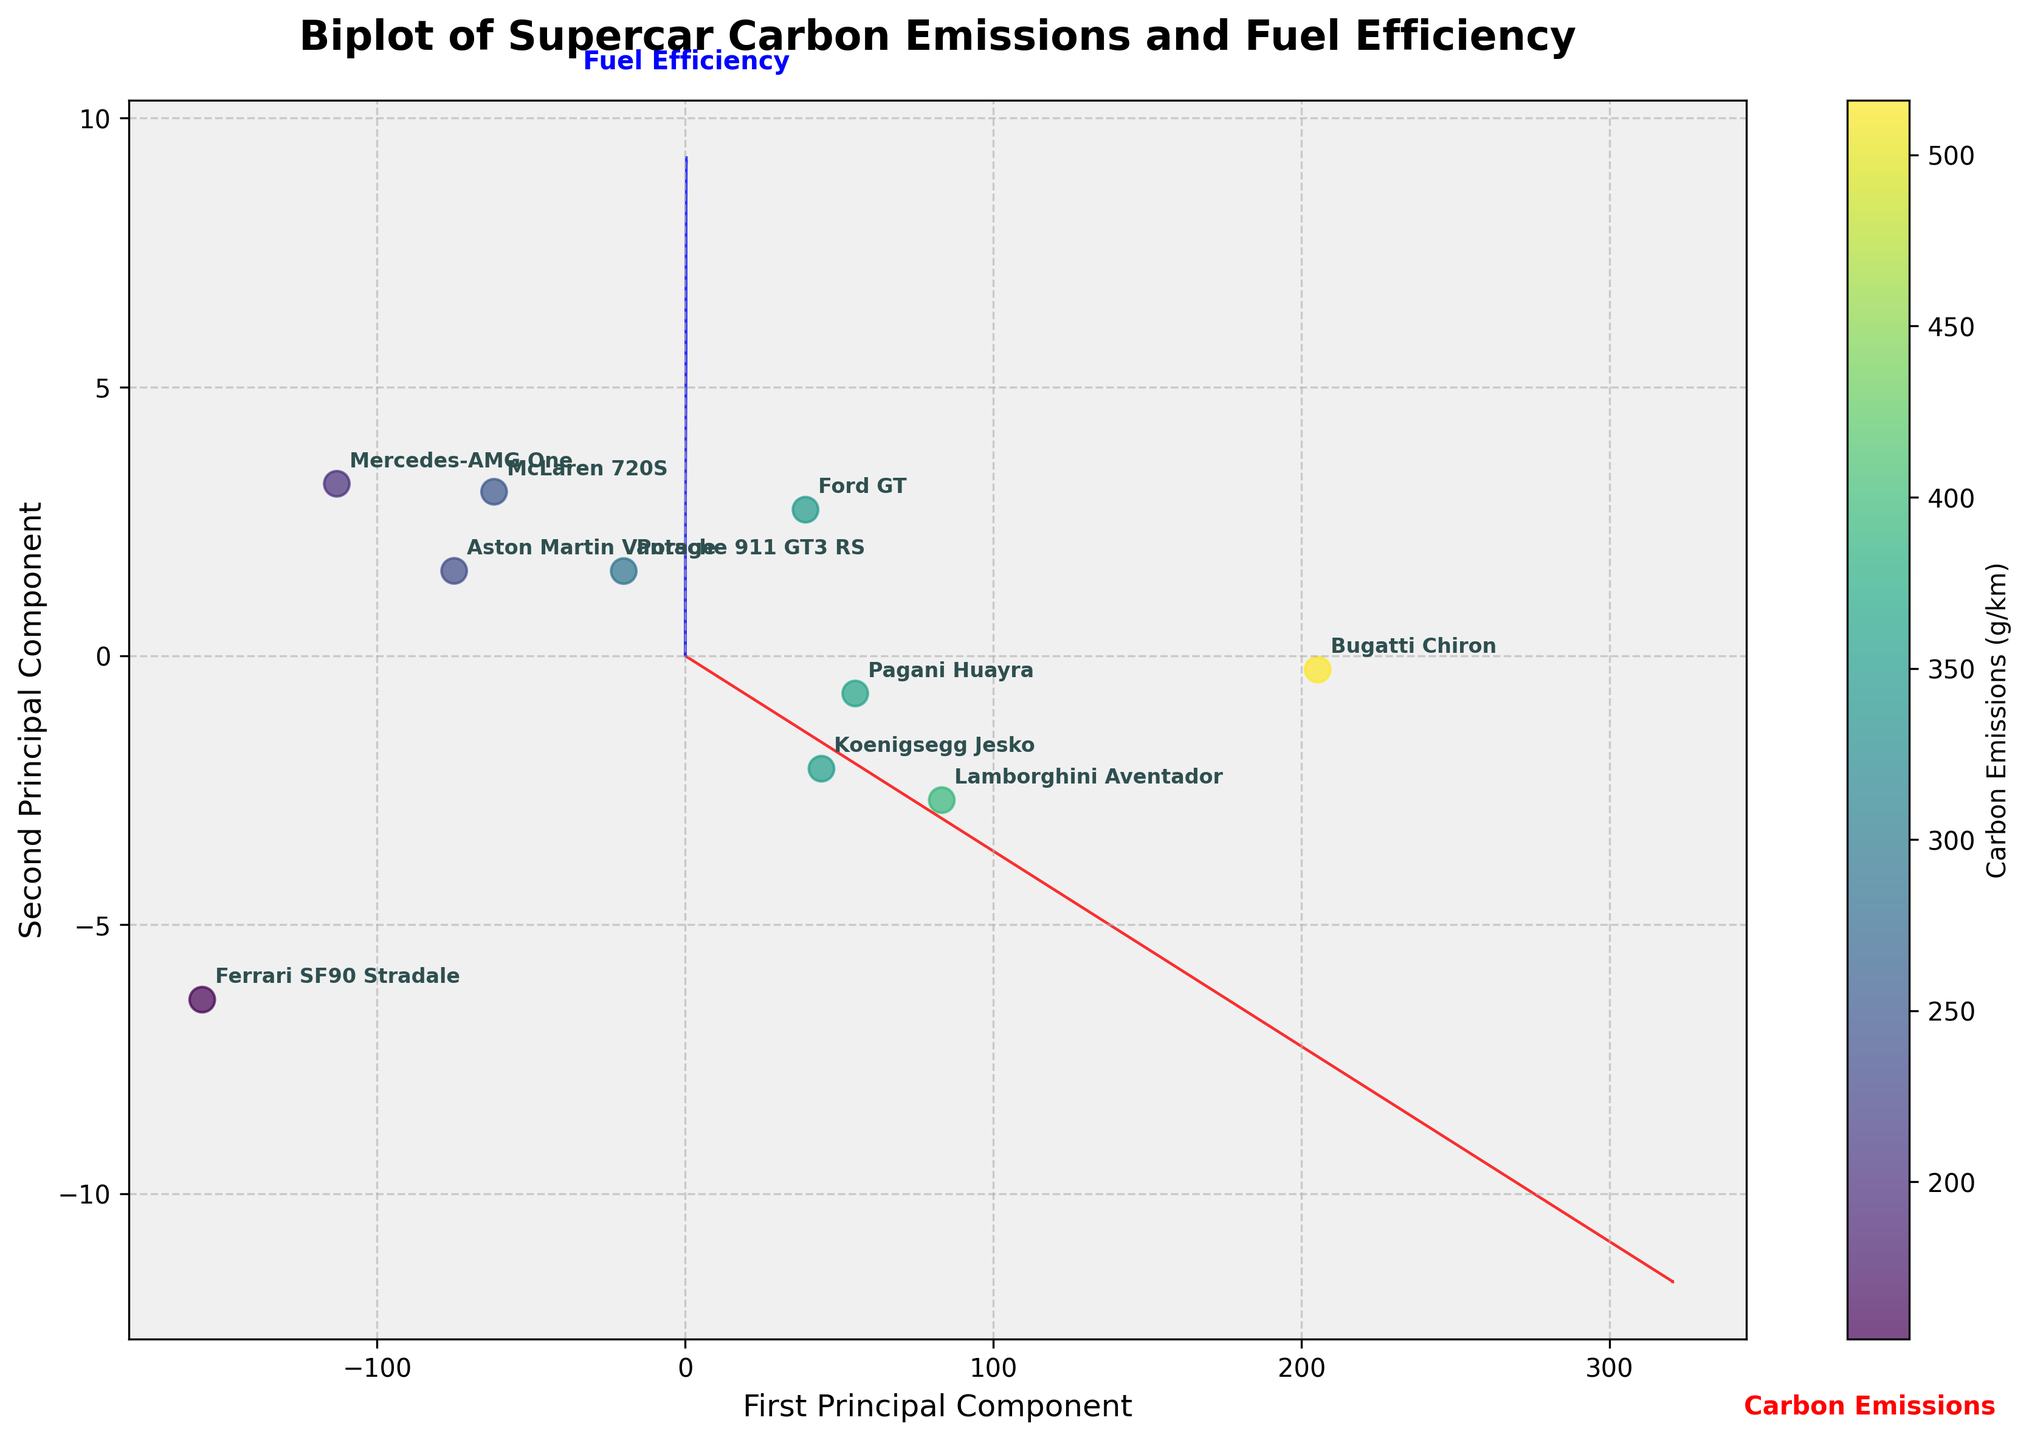Which brand has the highest carbon emissions according to the plot? By observing the dispersion of data points and their corresponding annotations, the point furthest on the carbon emissions scale correlates to Bugatti Chiron.
Answer: Bugatti Chiron What are the two principal components labeled in the plot? Look at the axes labels to find the names of the components. The x-axis is labeled “First Principal Component” and the y-axis is labeled “Second Principal Component”.
Answer: First Principal Component, Second Principal Component Which brand has the highest fuel efficiency according to the plot? Identify the brand located on the higher part of the y-axis labeled with higher values of "Fuel Efficiency (mpg)". The Mercedes-AMG One data point is located there.
Answer: Mercedes-AMG One Which brand is closest to the origin on the plot? The origin is the point (0,0). The brand that appears visually nearest to this point upon inspection is Ferrari SF90 Stradale.
Answer: Ferrari SF90 Stradale Compare the carbon emissions of McLaren 720S and Porsche 911 GT3 RS. Which is greater? Identify the placement of data points for McLaren 720S and Porsche 911 GT3 RS along the carbon emissions vector. Porsche 911 GT3 RS is placed higher than McLaren 720S on this scale.
Answer: Porsche 911 GT3 RS How many brands are plotted on the biplot? Count each annotated brand name in the plot. There are 10 distinct brands listed.
Answer: 10 Are there any brands with equivalent fuel efficiency ratings? Compare the arrangement of points on the y-axis labeled "Fuel Efficiency (mpg)". Ferrari SF90 Stradale and Porsche 911 GT3 RS both have the same appearance indicating similar EMS value.
Answer: Ferrari SF90 Stradale, Porsche 911 GT3 RS Which feature has a positive correlation with the first principal component? Look where the direction of the feature vectors are pointing. The vector for "Carbon Emissions" points to the right in the positive direction of the first principal component.
Answer: Carbon Emissions Which two brands have the closest principal component scores? Identify two points on the plot that appear closest to each other. McLaren 720S and Aston Martin Vantage occupy nearly the same spot.
Answer: McLaren 720S, Aston Martin Vantage What is the direction and color of the vector representing fuel efficiency? Check the specific vector associated with "Fuel Efficiency"; it points in a certain direction and has a color coded as blue in the plot.
Answer: Upward, Blue 